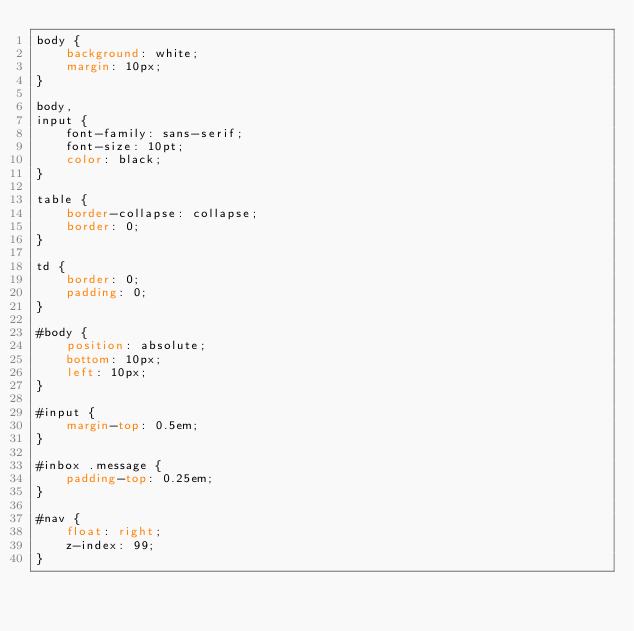<code> <loc_0><loc_0><loc_500><loc_500><_CSS_>body {
    background: white;
    margin: 10px;
}

body,
input {
    font-family: sans-serif;
    font-size: 10pt;
    color: black;
}

table {
    border-collapse: collapse;
    border: 0;
}

td {
    border: 0;
    padding: 0;
}

#body {
    position: absolute;
    bottom: 10px;
    left: 10px;
}

#input {
    margin-top: 0.5em;
}

#inbox .message {
    padding-top: 0.25em;
}

#nav {
    float: right;
    z-index: 99;
}</code> 